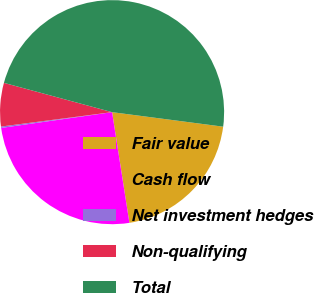Convert chart to OTSL. <chart><loc_0><loc_0><loc_500><loc_500><pie_chart><fcel>Fair value<fcel>Cash flow<fcel>Net investment hedges<fcel>Non-qualifying<fcel>Total<nl><fcel>20.46%<fcel>25.22%<fcel>0.2%<fcel>6.26%<fcel>47.86%<nl></chart> 